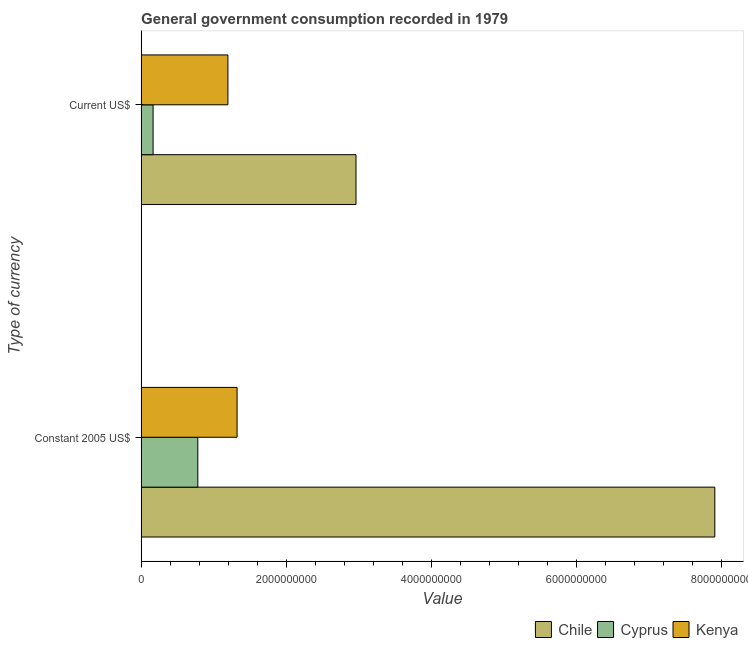How many different coloured bars are there?
Your answer should be very brief. 3. How many groups of bars are there?
Give a very brief answer. 2. Are the number of bars per tick equal to the number of legend labels?
Make the answer very short. Yes. What is the label of the 1st group of bars from the top?
Give a very brief answer. Current US$. What is the value consumed in constant 2005 us$ in Kenya?
Your answer should be very brief. 1.32e+09. Across all countries, what is the maximum value consumed in current us$?
Make the answer very short. 2.96e+09. Across all countries, what is the minimum value consumed in constant 2005 us$?
Your response must be concise. 7.82e+08. In which country was the value consumed in current us$ maximum?
Your response must be concise. Chile. In which country was the value consumed in current us$ minimum?
Give a very brief answer. Cyprus. What is the total value consumed in current us$ in the graph?
Provide a succinct answer. 4.32e+09. What is the difference between the value consumed in current us$ in Kenya and that in Chile?
Your answer should be compact. -1.77e+09. What is the difference between the value consumed in current us$ in Chile and the value consumed in constant 2005 us$ in Cyprus?
Make the answer very short. 2.18e+09. What is the average value consumed in constant 2005 us$ per country?
Make the answer very short. 3.34e+09. What is the difference between the value consumed in constant 2005 us$ and value consumed in current us$ in Chile?
Offer a very short reply. 4.95e+09. In how many countries, is the value consumed in constant 2005 us$ greater than 1200000000 ?
Your answer should be very brief. 2. What is the ratio of the value consumed in current us$ in Cyprus to that in Chile?
Give a very brief answer. 0.06. Is the value consumed in current us$ in Kenya less than that in Cyprus?
Keep it short and to the point. No. In how many countries, is the value consumed in current us$ greater than the average value consumed in current us$ taken over all countries?
Your response must be concise. 1. What does the 2nd bar from the top in Constant 2005 US$ represents?
Ensure brevity in your answer.  Cyprus. What does the 1st bar from the bottom in Current US$ represents?
Your answer should be compact. Chile. How many bars are there?
Keep it short and to the point. 6. Are all the bars in the graph horizontal?
Offer a very short reply. Yes. How many countries are there in the graph?
Your response must be concise. 3. What is the difference between two consecutive major ticks on the X-axis?
Your answer should be very brief. 2.00e+09. Are the values on the major ticks of X-axis written in scientific E-notation?
Give a very brief answer. No. Does the graph contain grids?
Keep it short and to the point. No. Where does the legend appear in the graph?
Provide a short and direct response. Bottom right. How many legend labels are there?
Provide a succinct answer. 3. What is the title of the graph?
Your response must be concise. General government consumption recorded in 1979. Does "Central Europe" appear as one of the legend labels in the graph?
Keep it short and to the point. No. What is the label or title of the X-axis?
Your answer should be compact. Value. What is the label or title of the Y-axis?
Your answer should be compact. Type of currency. What is the Value in Chile in Constant 2005 US$?
Keep it short and to the point. 7.91e+09. What is the Value in Cyprus in Constant 2005 US$?
Provide a succinct answer. 7.82e+08. What is the Value of Kenya in Constant 2005 US$?
Provide a succinct answer. 1.32e+09. What is the Value of Chile in Current US$?
Provide a succinct answer. 2.96e+09. What is the Value of Cyprus in Current US$?
Your answer should be compact. 1.65e+08. What is the Value of Kenya in Current US$?
Keep it short and to the point. 1.20e+09. Across all Type of currency, what is the maximum Value in Chile?
Offer a very short reply. 7.91e+09. Across all Type of currency, what is the maximum Value in Cyprus?
Your answer should be very brief. 7.82e+08. Across all Type of currency, what is the maximum Value in Kenya?
Make the answer very short. 1.32e+09. Across all Type of currency, what is the minimum Value of Chile?
Keep it short and to the point. 2.96e+09. Across all Type of currency, what is the minimum Value of Cyprus?
Your answer should be compact. 1.65e+08. Across all Type of currency, what is the minimum Value in Kenya?
Offer a terse response. 1.20e+09. What is the total Value in Chile in the graph?
Your answer should be very brief. 1.09e+1. What is the total Value in Cyprus in the graph?
Your response must be concise. 9.46e+08. What is the total Value in Kenya in the graph?
Provide a short and direct response. 2.52e+09. What is the difference between the Value of Chile in Constant 2005 US$ and that in Current US$?
Keep it short and to the point. 4.95e+09. What is the difference between the Value in Cyprus in Constant 2005 US$ and that in Current US$?
Make the answer very short. 6.17e+08. What is the difference between the Value of Kenya in Constant 2005 US$ and that in Current US$?
Your answer should be very brief. 1.26e+08. What is the difference between the Value in Chile in Constant 2005 US$ and the Value in Cyprus in Current US$?
Provide a succinct answer. 7.75e+09. What is the difference between the Value of Chile in Constant 2005 US$ and the Value of Kenya in Current US$?
Your answer should be very brief. 6.72e+09. What is the difference between the Value of Cyprus in Constant 2005 US$ and the Value of Kenya in Current US$?
Provide a short and direct response. -4.15e+08. What is the average Value of Chile per Type of currency?
Make the answer very short. 5.44e+09. What is the average Value of Cyprus per Type of currency?
Offer a very short reply. 4.73e+08. What is the average Value of Kenya per Type of currency?
Offer a very short reply. 1.26e+09. What is the difference between the Value in Chile and Value in Cyprus in Constant 2005 US$?
Offer a terse response. 7.13e+09. What is the difference between the Value in Chile and Value in Kenya in Constant 2005 US$?
Ensure brevity in your answer.  6.59e+09. What is the difference between the Value in Cyprus and Value in Kenya in Constant 2005 US$?
Your answer should be compact. -5.42e+08. What is the difference between the Value in Chile and Value in Cyprus in Current US$?
Offer a very short reply. 2.80e+09. What is the difference between the Value in Chile and Value in Kenya in Current US$?
Your answer should be compact. 1.77e+09. What is the difference between the Value of Cyprus and Value of Kenya in Current US$?
Offer a terse response. -1.03e+09. What is the ratio of the Value of Chile in Constant 2005 US$ to that in Current US$?
Ensure brevity in your answer.  2.67. What is the ratio of the Value of Cyprus in Constant 2005 US$ to that in Current US$?
Provide a succinct answer. 4.75. What is the ratio of the Value of Kenya in Constant 2005 US$ to that in Current US$?
Offer a very short reply. 1.11. What is the difference between the highest and the second highest Value of Chile?
Make the answer very short. 4.95e+09. What is the difference between the highest and the second highest Value of Cyprus?
Make the answer very short. 6.17e+08. What is the difference between the highest and the second highest Value in Kenya?
Keep it short and to the point. 1.26e+08. What is the difference between the highest and the lowest Value in Chile?
Offer a terse response. 4.95e+09. What is the difference between the highest and the lowest Value of Cyprus?
Your answer should be very brief. 6.17e+08. What is the difference between the highest and the lowest Value of Kenya?
Your answer should be very brief. 1.26e+08. 